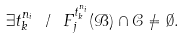Convert formula to latex. <formula><loc_0><loc_0><loc_500><loc_500>\exists t _ { k } ^ { n _ { i } } \text { } / \text { } { F } _ { j } ^ { t _ { k } ^ { n _ { i } } } ( \mathcal { B } ) \cap \mathcal { C } \neq \emptyset .</formula> 